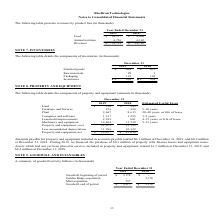From Ricebran Technologies's financial document, What are the respective values of finished goods in 2018 and 2019? The document shows two values: $853 and $698 (in thousands). From the document: "Finished goods 698 $ 853 $ Finished goods 698 $ 853 $..." Also, What are the respective values of raw materials in 2018 and 2019? The document shows two values: 3 and 90 (in thousands). From the document: "Raw materials 90 3 Raw materials 90 3..." Also, What are the respective values of packaging in 2018 and 2019? The document shows two values: 102 and 110 (in thousands). From the document: "Packaging 110 102 Packaging 110 102..." Also, can you calculate: What is the average value of finished goods in 2018 and 2019? To answer this question, I need to perform calculations using the financial data. The calculation is: (853 + 698)/2 , which equals 775.5 (in thousands). This is based on the information: "Finished goods 698 $ 853 $ Finished goods 698 $ 853 $..." The key data points involved are: 698, 853. Also, can you calculate: What is the average value of raw materials in 2018 and 2019? To answer this question, I need to perform calculations using the financial data. The calculation is: (90 + 3)/2 , which equals 46.5 (in thousands). This is based on the information: "Raw materials 90 3 Raw materials 90 3..." The key data points involved are: 3, 90. Also, can you calculate: What is the average value of packaging in 2018 and 2019? To answer this question, I need to perform calculations using the financial data. The calculation is: (110 + 102)/2 , which equals 106 (in thousands). This is based on the information: "Packaging 110 102 Packaging 110 102..." The key data points involved are: 102, 110. 